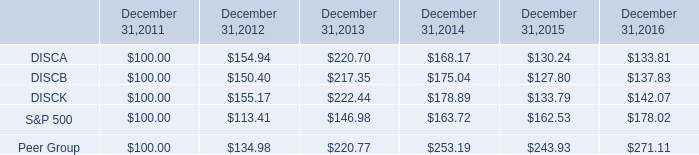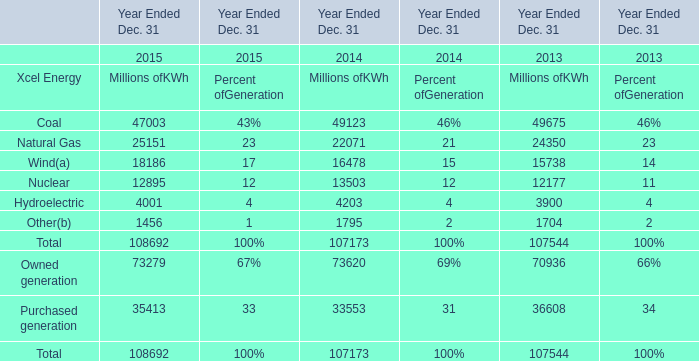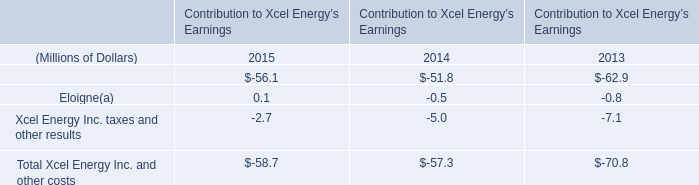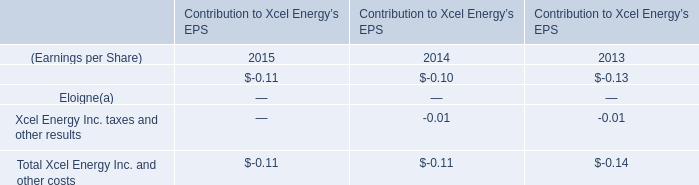what was the percentage cumulative total shareholder return on discb for the five year period ended december 31 , 2016? 
Computations: ((137.83 - 100) / 100)
Answer: 0.3783. 